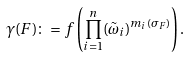<formula> <loc_0><loc_0><loc_500><loc_500>\gamma ( F ) \colon = f \left ( \prod _ { i = 1 } ^ { n } ( \tilde { \omega } _ { i } ) ^ { m _ { i } ( \sigma _ { F } ) } \right ) .</formula> 